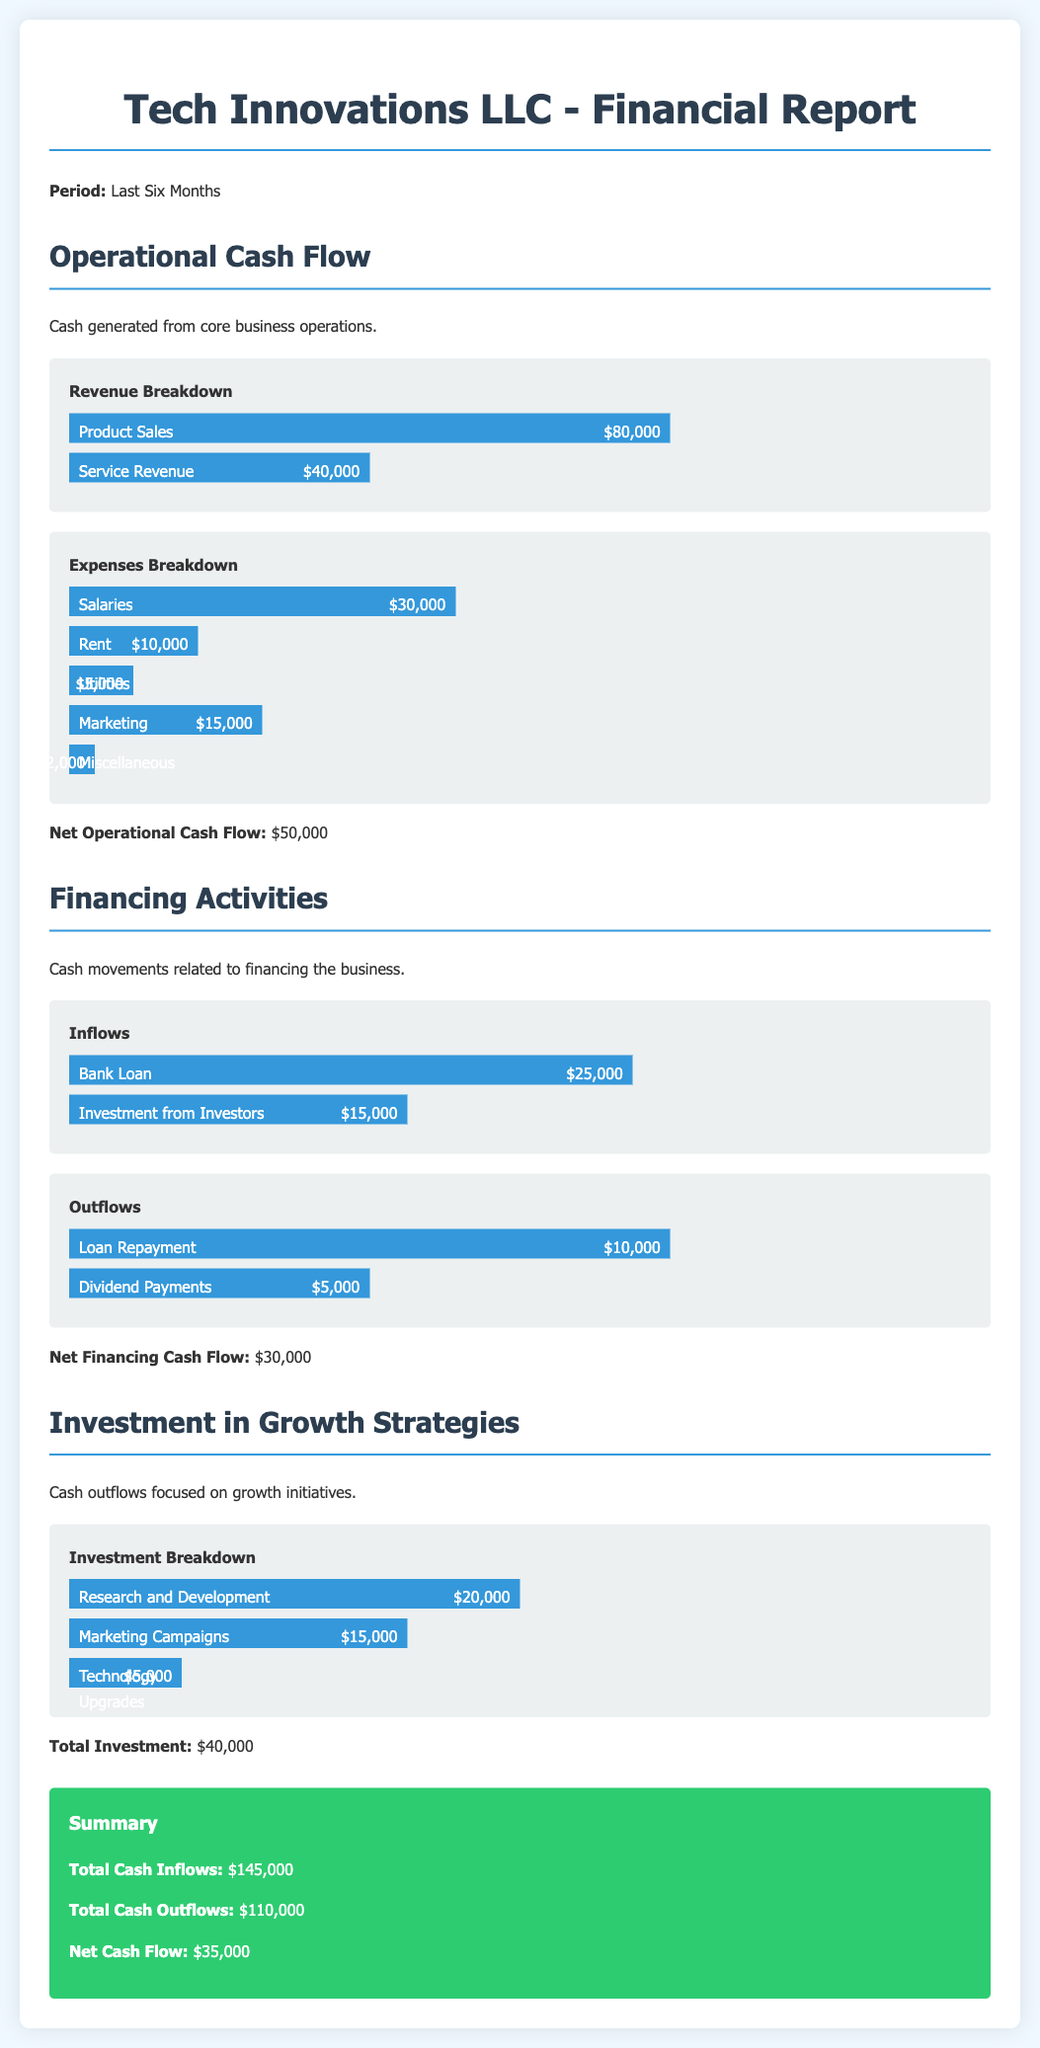What was the total product sales revenue? The total product sales revenue is detailed under operational cash flow, specifically labeled as product sales, which amounts to $80,000.
Answer: $80,000 What is the net operational cash flow? The net operational cash flow is provided at the end of the operational cash flow section, showing the figure after expenses, which totals $50,000.
Answer: $50,000 What were the dividends paid out in the financing activities? The dividends are listed in the financing outflows section, which indicates $5,000 in dividend payments.
Answer: $5,000 What is the total cash inflows for the period? The total cash inflows can be found in the summary section, where it states that total cash inflows are $145,000.
Answer: $145,000 How much was invested in research and development? The investment breakdown details that $20,000 was allocated to research and development initiatives under investment in growth strategies.
Answer: $20,000 What is the total cash outflows amount? Total cash outflows are summarized, showing the total amount of cash went out as $110,000.
Answer: $110,000 What percentage of total expenses is attributed to salaries? To find the percentage, compare the salaries expense of $30,000 against the total expenses, which totals $70,000 (the sum of all expenses). So, $30,000 / $70,000 = 42.86%.
Answer: 42.86% What was the net cash flow for the last six months? The net cash flow is mentioned in the summary section, indicating the total difference between cash inflows and outflows, and it is $35,000.
Answer: $35,000 What amount was spent on marketing campaigns? Under investment in growth strategies, it is specified that $15,000 was spent on marketing campaigns.
Answer: $15,000 